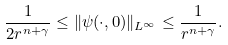<formula> <loc_0><loc_0><loc_500><loc_500>\frac { 1 } { 2 r ^ { n + \gamma } } \leq \| \psi ( \cdot , 0 ) \| _ { L ^ { \infty } } \leq \frac { 1 } { r ^ { n + \gamma } } .</formula> 